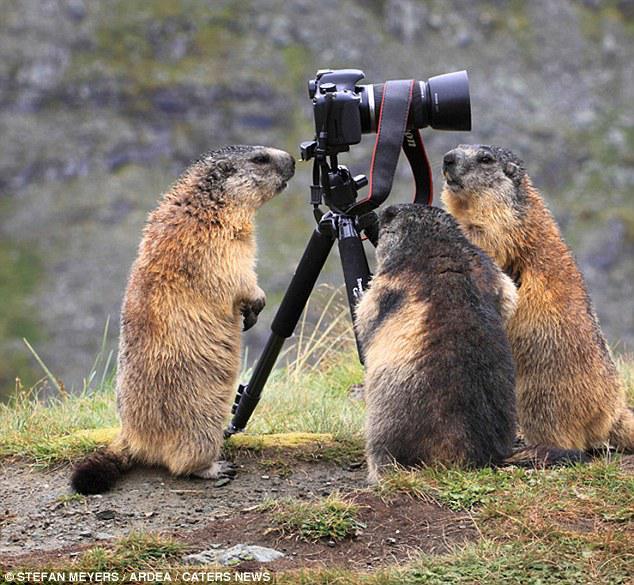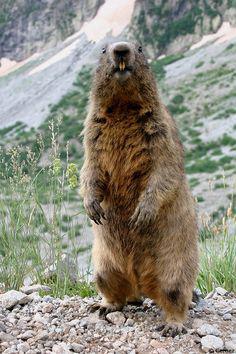The first image is the image on the left, the second image is the image on the right. Considering the images on both sides, is "There are two marmots, and both stand upright with front paws dangling." valid? Answer yes or no. No. The first image is the image on the left, the second image is the image on the right. For the images displayed, is the sentence "At least one animal in the image on the left is standing near a piece of manmade equipment." factually correct? Answer yes or no. Yes. 